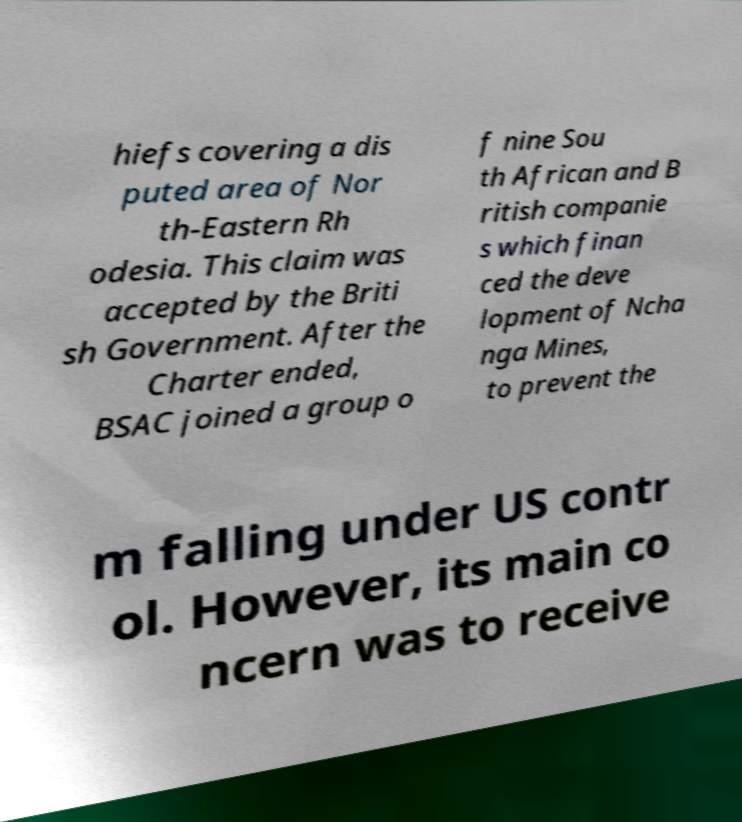For documentation purposes, I need the text within this image transcribed. Could you provide that? hiefs covering a dis puted area of Nor th-Eastern Rh odesia. This claim was accepted by the Briti sh Government. After the Charter ended, BSAC joined a group o f nine Sou th African and B ritish companie s which finan ced the deve lopment of Ncha nga Mines, to prevent the m falling under US contr ol. However, its main co ncern was to receive 